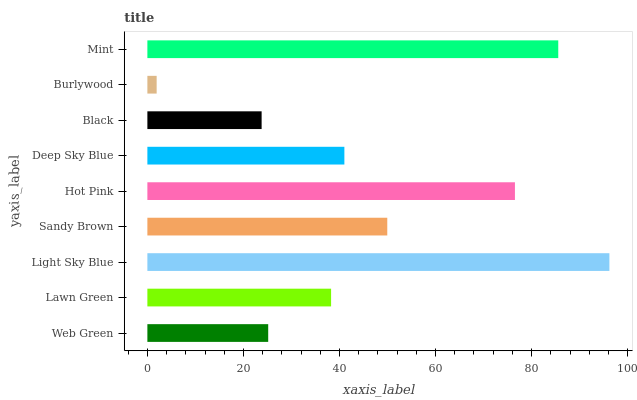Is Burlywood the minimum?
Answer yes or no. Yes. Is Light Sky Blue the maximum?
Answer yes or no. Yes. Is Lawn Green the minimum?
Answer yes or no. No. Is Lawn Green the maximum?
Answer yes or no. No. Is Lawn Green greater than Web Green?
Answer yes or no. Yes. Is Web Green less than Lawn Green?
Answer yes or no. Yes. Is Web Green greater than Lawn Green?
Answer yes or no. No. Is Lawn Green less than Web Green?
Answer yes or no. No. Is Deep Sky Blue the high median?
Answer yes or no. Yes. Is Deep Sky Blue the low median?
Answer yes or no. Yes. Is Web Green the high median?
Answer yes or no. No. Is Hot Pink the low median?
Answer yes or no. No. 